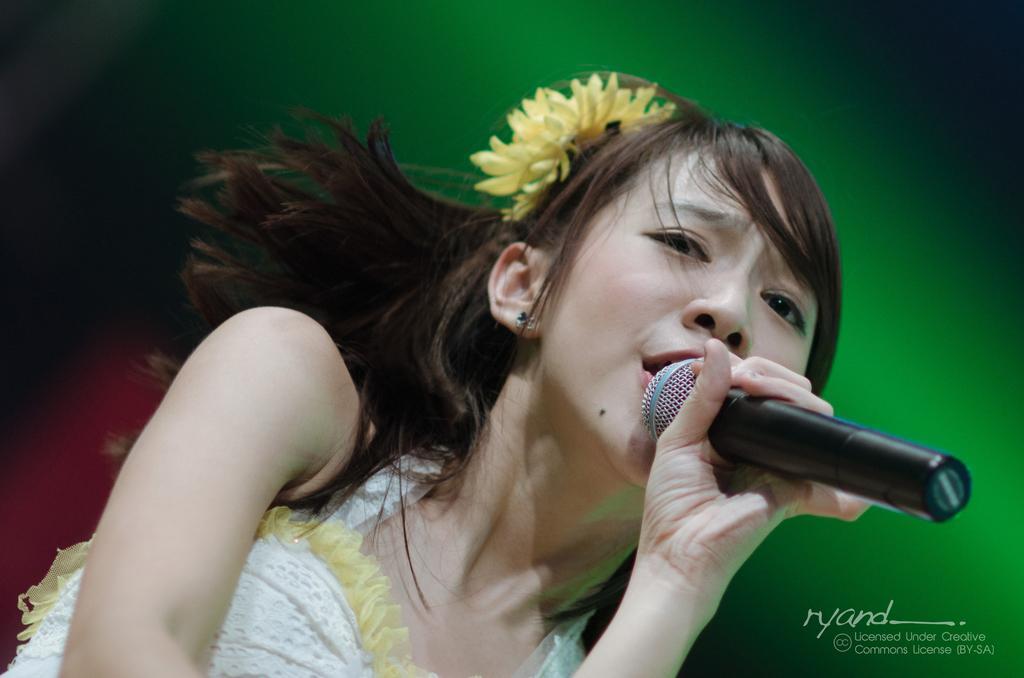Describe this image in one or two sentences. This is the woman holding mike and signing a song. She wore white dress. This is a yellow flower on her head. Background is green in color. 